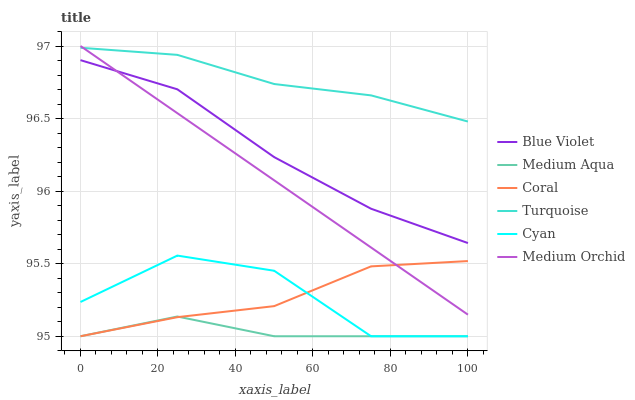Does Medium Aqua have the minimum area under the curve?
Answer yes or no. Yes. Does Turquoise have the maximum area under the curve?
Answer yes or no. Yes. Does Coral have the minimum area under the curve?
Answer yes or no. No. Does Coral have the maximum area under the curve?
Answer yes or no. No. Is Medium Orchid the smoothest?
Answer yes or no. Yes. Is Cyan the roughest?
Answer yes or no. Yes. Is Coral the smoothest?
Answer yes or no. No. Is Coral the roughest?
Answer yes or no. No. Does Coral have the lowest value?
Answer yes or no. Yes. Does Medium Orchid have the lowest value?
Answer yes or no. No. Does Medium Orchid have the highest value?
Answer yes or no. Yes. Does Coral have the highest value?
Answer yes or no. No. Is Cyan less than Blue Violet?
Answer yes or no. Yes. Is Medium Orchid greater than Cyan?
Answer yes or no. Yes. Does Medium Aqua intersect Cyan?
Answer yes or no. Yes. Is Medium Aqua less than Cyan?
Answer yes or no. No. Is Medium Aqua greater than Cyan?
Answer yes or no. No. Does Cyan intersect Blue Violet?
Answer yes or no. No. 